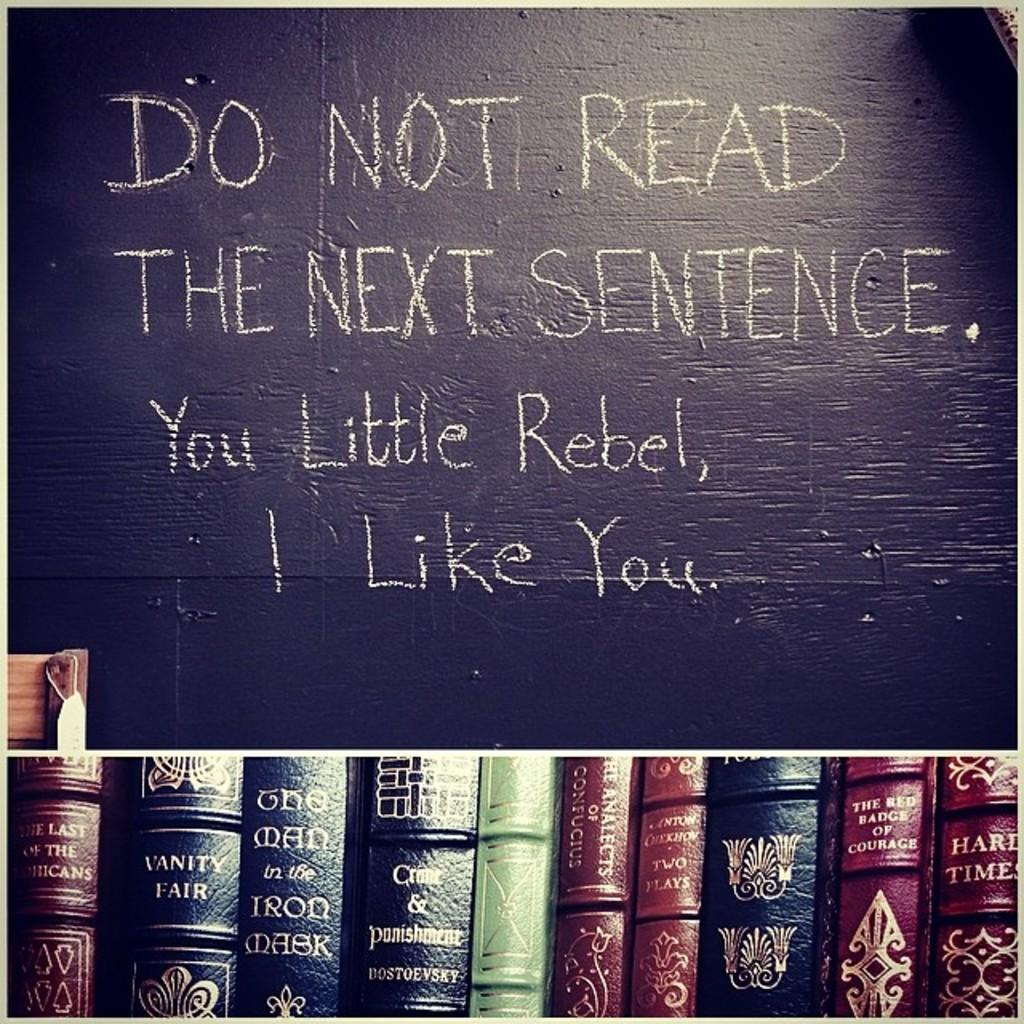Provide a one-sentence caption for the provided image. A sign displayed above books stays Do Not Read The Next Sentence. 